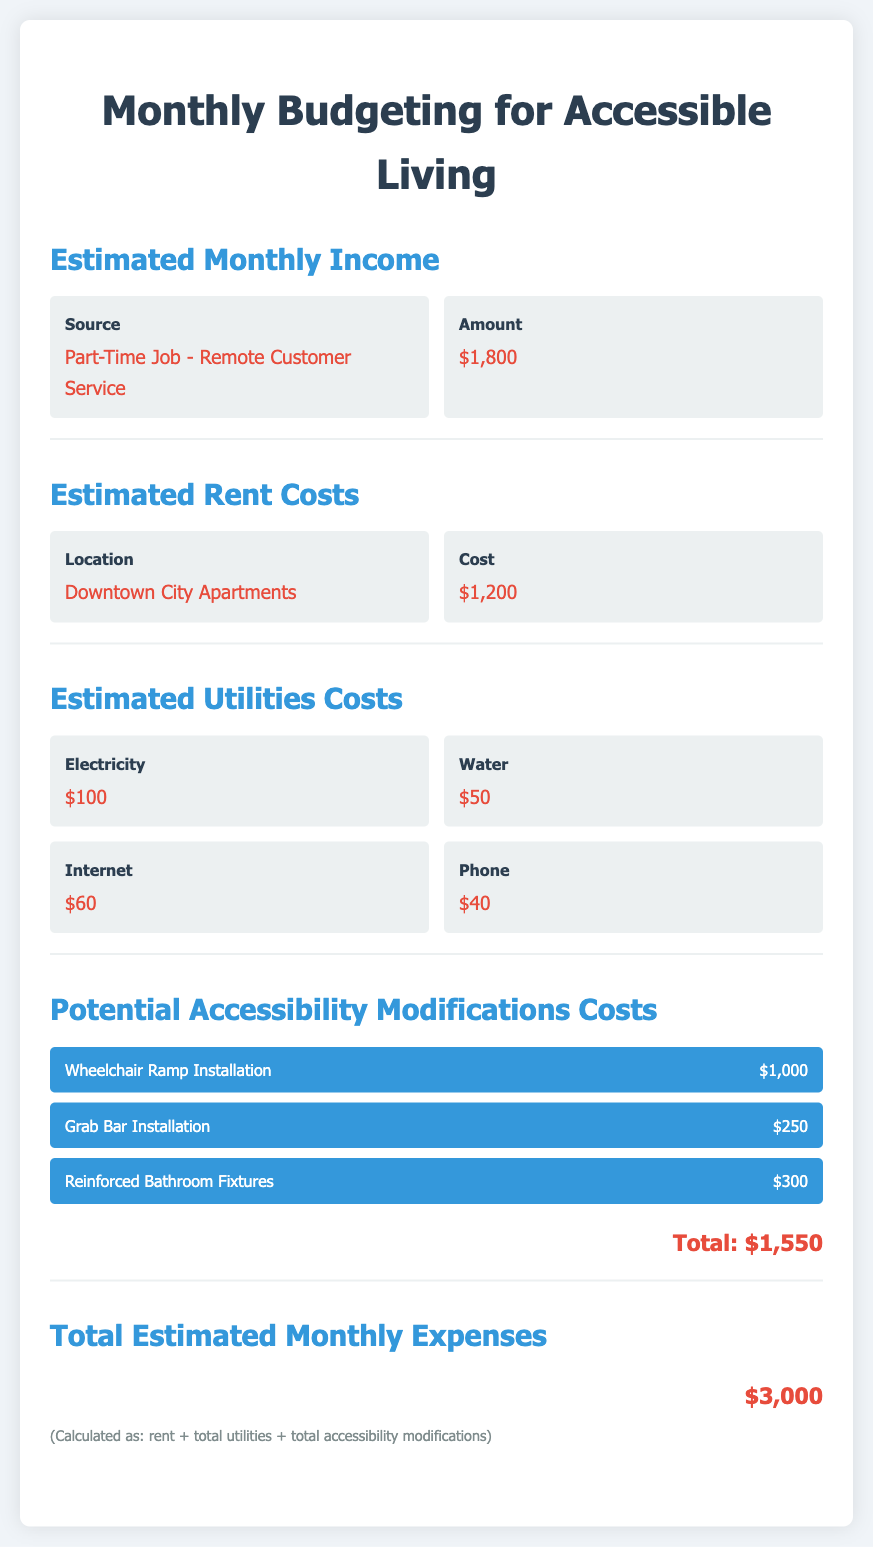What is the estimated rent cost? The estimated rent cost is provided in the document, specifically noted under rent costs.
Answer: $1,200 How much are the total utilities costs? The total utilities costs are the sum of all the utility expenses listed in the document: electricity, water, internet, and phone.
Answer: $250 What is the total cost for accessibility modifications? The total for accessibility modifications is explicitly mentioned in the document as a separate section.
Answer: $1,550 What is the estimated monthly income? The estimated monthly income is specified under the monthly income section in the document.
Answer: $1,800 What is the total estimated monthly expense? The total estimated monthly expense is calculated and mentioned at the end of the budgeting summary.
Answer: $3,000 How many sources of income are mentioned? The document lists the sources of income under the estimated monthly income section.
Answer: 1 What installation costs are associated with wheelchair access? The document lists specific installation costs related to accessibility in its accessibility modifications section.
Answer: $1,000 What type of apartment is being considered? The type of apartment is specified in the estimated rent costs section.
Answer: Downtown City Apartments 